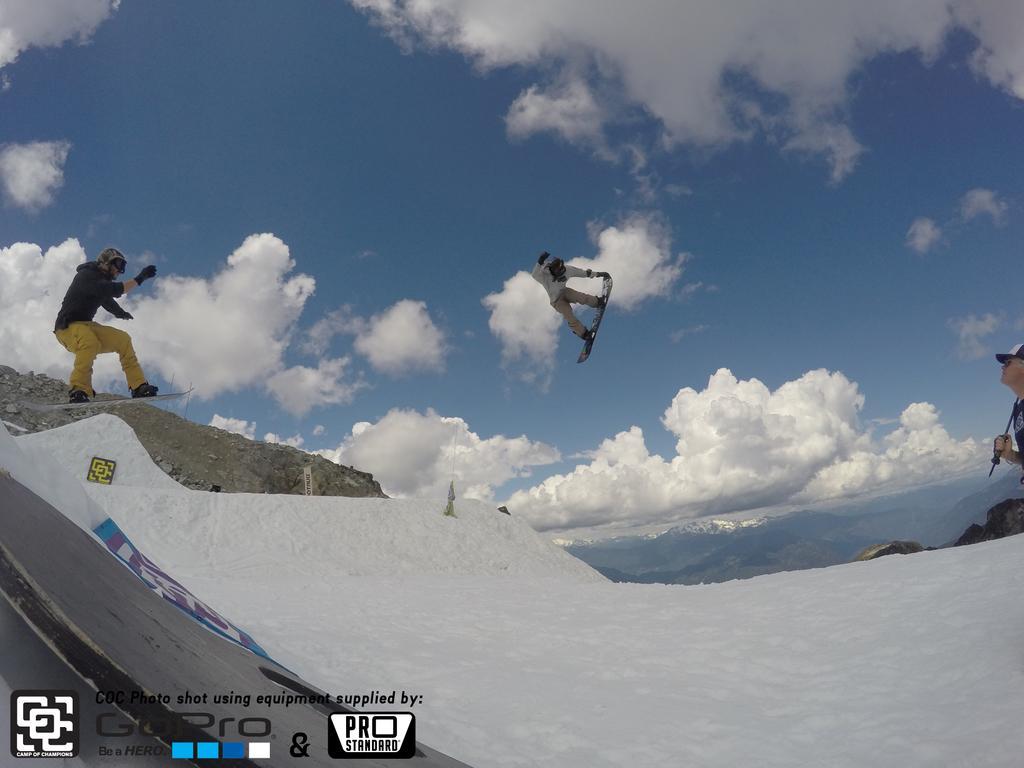In one or two sentences, can you explain what this image depicts? This image consists of two persons skiing. At the bottom, there is snow. In the background, there are clouds in the sky. 